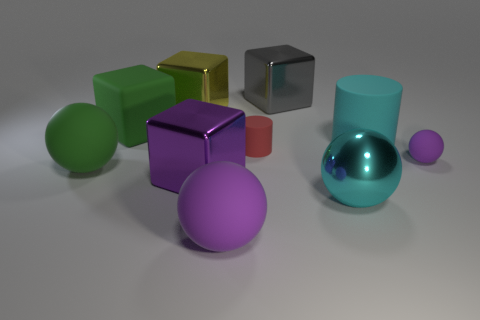Is the color of the cube that is to the left of the large yellow thing the same as the tiny matte sphere?
Offer a terse response. No. What number of things are either big yellow things or big objects behind the large cyan matte cylinder?
Ensure brevity in your answer.  3. Does the cyan thing in front of the cyan matte thing have the same shape as the large green thing in front of the large cyan matte object?
Provide a succinct answer. Yes. Is there any other thing that is the same color as the small cylinder?
Provide a short and direct response. No. What is the shape of the big cyan object that is the same material as the big gray block?
Provide a short and direct response. Sphere. There is a thing that is behind the small purple ball and left of the yellow metallic cube; what is its material?
Ensure brevity in your answer.  Rubber. Is there anything else that is the same size as the green sphere?
Your answer should be very brief. Yes. Is the matte block the same color as the tiny matte sphere?
Ensure brevity in your answer.  No. The thing that is the same color as the rubber cube is what shape?
Provide a succinct answer. Sphere. How many purple shiny things have the same shape as the big gray metallic object?
Provide a short and direct response. 1. 